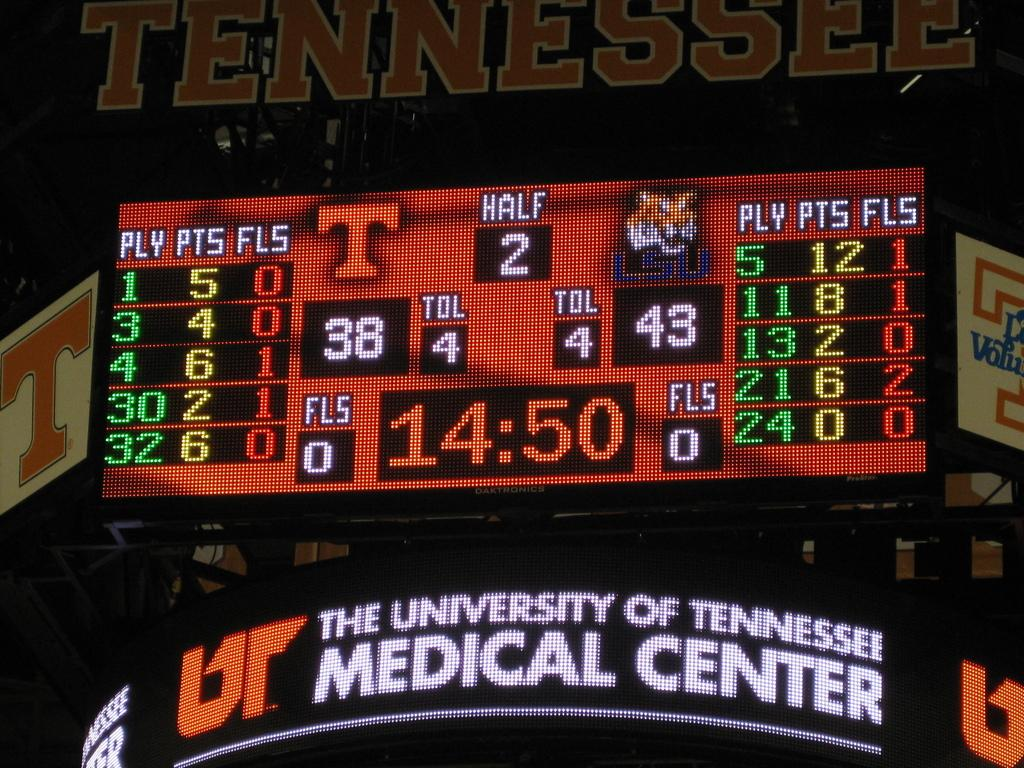<image>
Share a concise interpretation of the image provided. A sign reads "The University of Tennessee Medical Center" under a scoreboard. 